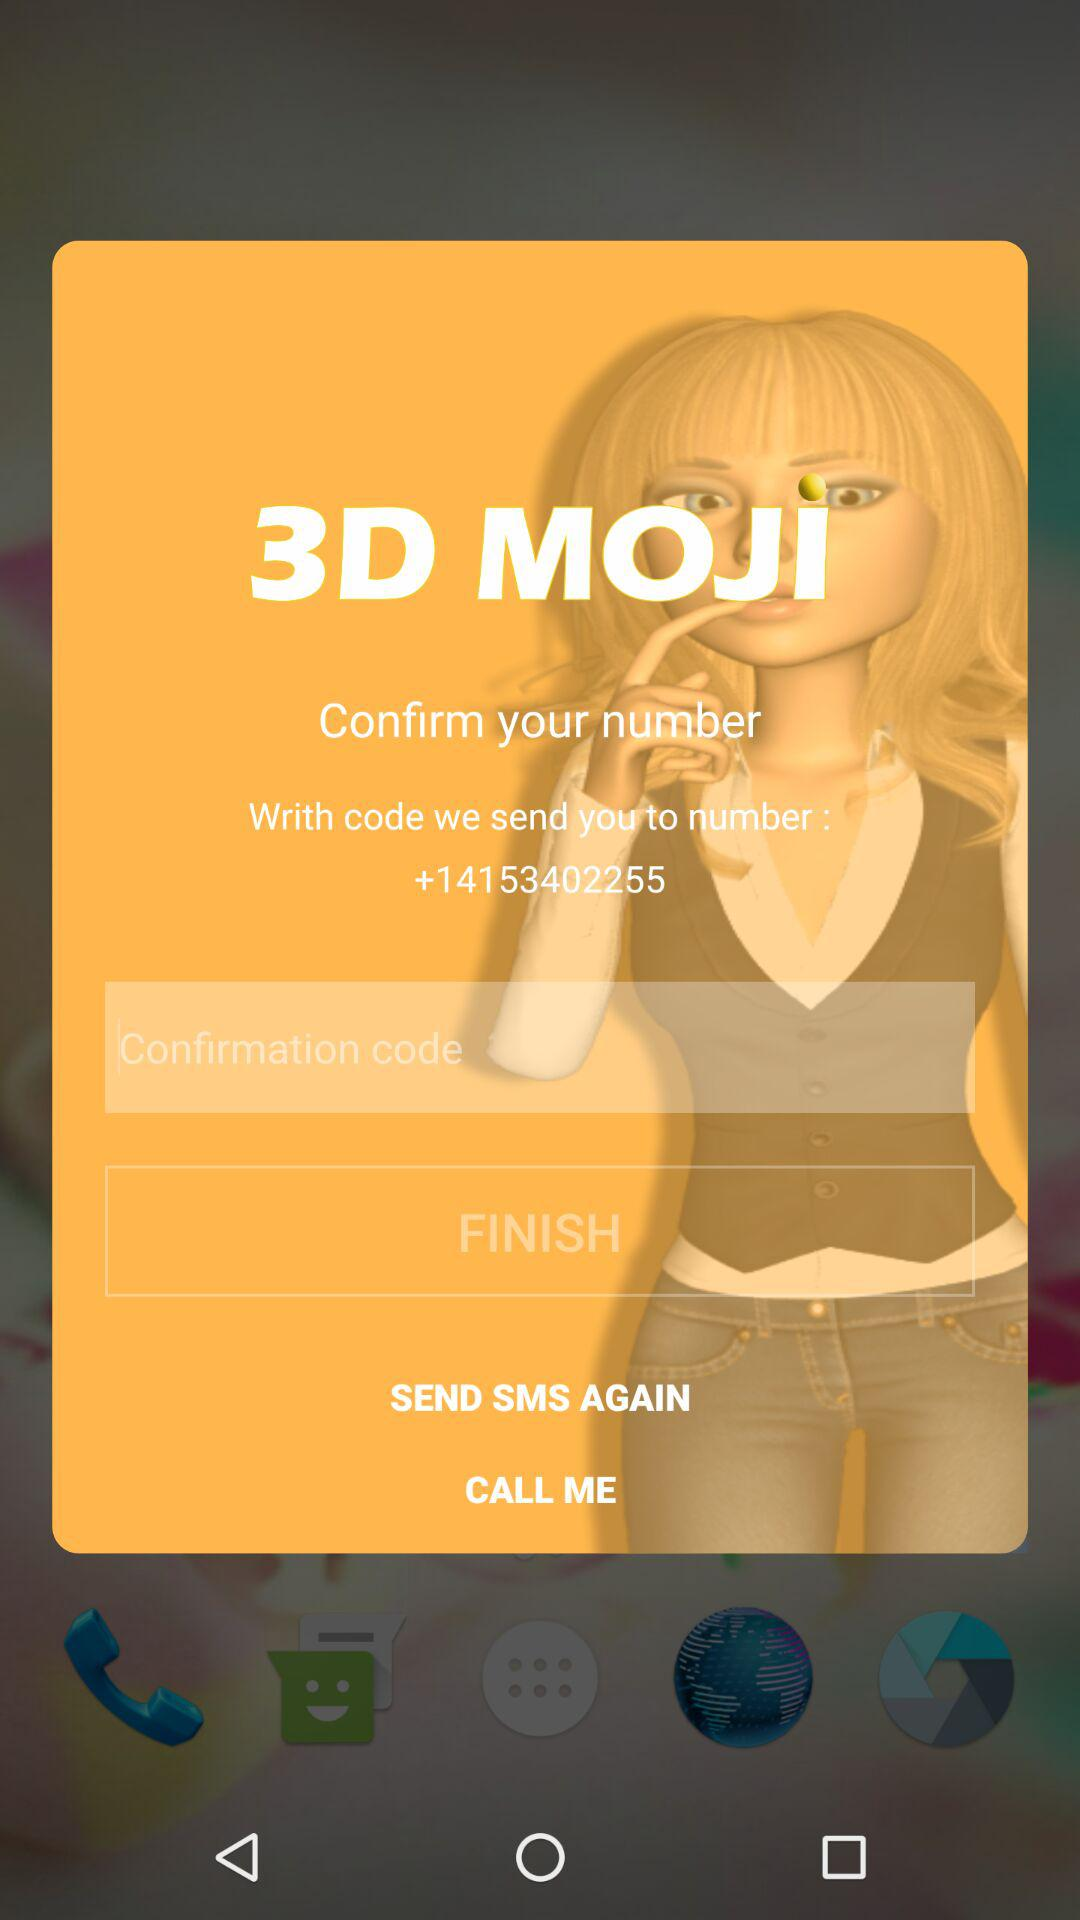What is the application name? The application name is "3D MOJI". 